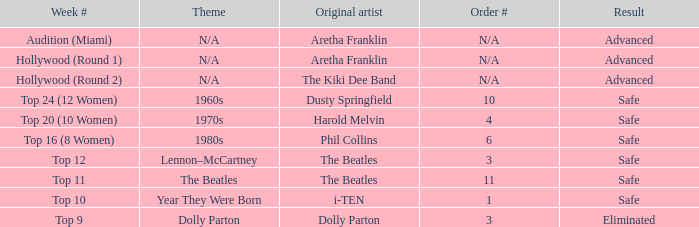For the order with aretha franklin as the original artist, what is its numerical position? N/A, N/A. Would you be able to parse every entry in this table? {'header': ['Week #', 'Theme', 'Original artist', 'Order #', 'Result'], 'rows': [['Audition (Miami)', 'N/A', 'Aretha Franklin', 'N/A', 'Advanced'], ['Hollywood (Round 1)', 'N/A', 'Aretha Franklin', 'N/A', 'Advanced'], ['Hollywood (Round 2)', 'N/A', 'The Kiki Dee Band', 'N/A', 'Advanced'], ['Top 24 (12 Women)', '1960s', 'Dusty Springfield', '10', 'Safe'], ['Top 20 (10 Women)', '1970s', 'Harold Melvin', '4', 'Safe'], ['Top 16 (8 Women)', '1980s', 'Phil Collins', '6', 'Safe'], ['Top 12', 'Lennon–McCartney', 'The Beatles', '3', 'Safe'], ['Top 11', 'The Beatles', 'The Beatles', '11', 'Safe'], ['Top 10', 'Year They Were Born', 'i-TEN', '1', 'Safe'], ['Top 9', 'Dolly Parton', 'Dolly Parton', '3', 'Eliminated']]} 